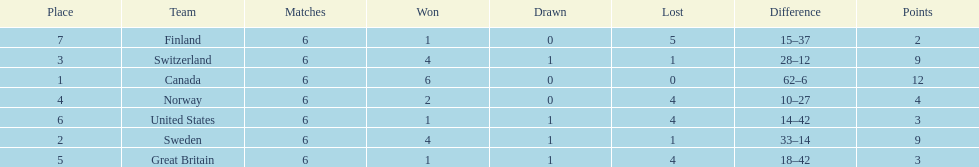How many teams won only 1 match? 3. 